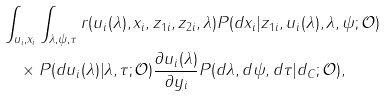<formula> <loc_0><loc_0><loc_500><loc_500>& \int _ { u _ { i } , x _ { i } } \int _ { \lambda , \psi , \tau } r ( u _ { i } ( \lambda ) , x _ { i } , z _ { 1 i } , z _ { 2 i } , \lambda ) P ( d x _ { i } | z _ { 1 i } , u _ { i } ( \lambda ) , \lambda , \psi ; \mathcal { O } ) \\ & \quad \times P ( d u _ { i } ( \lambda ) | \lambda , \tau ; \mathcal { O } ) \frac { \partial u _ { i } ( \lambda ) } { \partial y _ { i } } P ( d \lambda , d \psi , d \tau | d _ { C } ; \mathcal { O } ) ,</formula> 